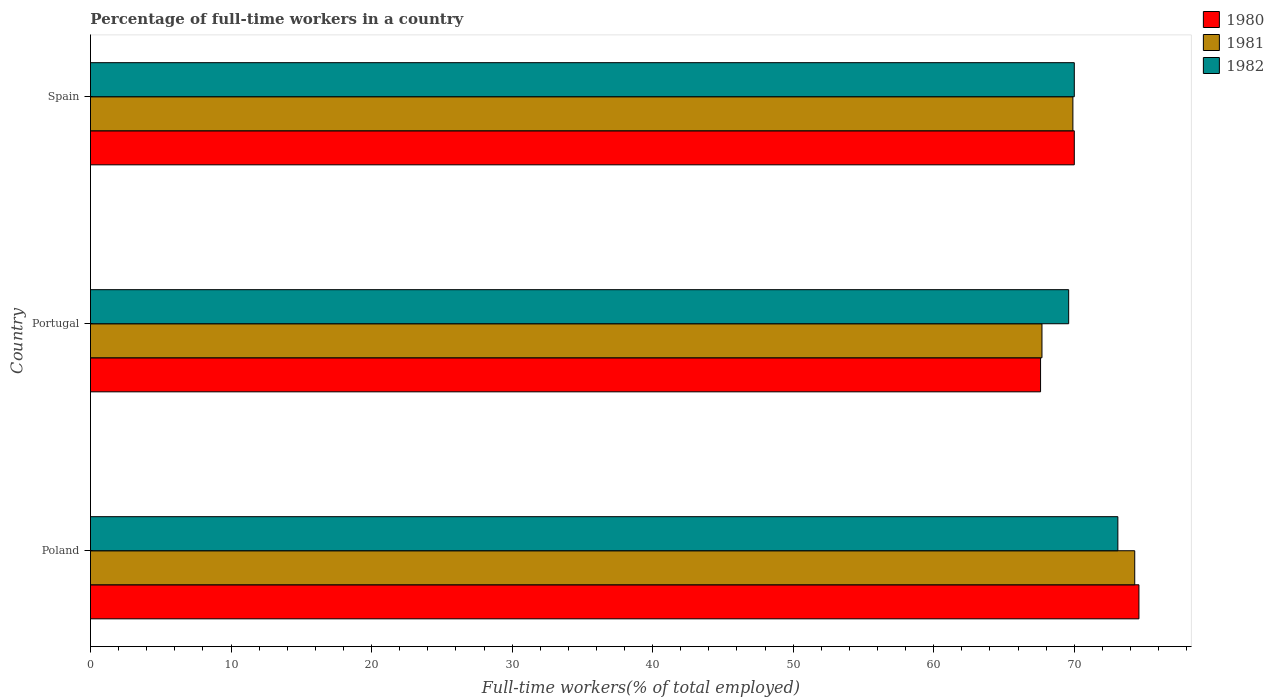How many different coloured bars are there?
Keep it short and to the point. 3. What is the label of the 1st group of bars from the top?
Provide a succinct answer. Spain. In how many cases, is the number of bars for a given country not equal to the number of legend labels?
Make the answer very short. 0. What is the percentage of full-time workers in 1981 in Portugal?
Ensure brevity in your answer.  67.7. Across all countries, what is the maximum percentage of full-time workers in 1982?
Keep it short and to the point. 73.1. Across all countries, what is the minimum percentage of full-time workers in 1981?
Your answer should be compact. 67.7. In which country was the percentage of full-time workers in 1981 maximum?
Your answer should be compact. Poland. What is the total percentage of full-time workers in 1980 in the graph?
Provide a short and direct response. 212.2. What is the difference between the percentage of full-time workers in 1981 in Poland and that in Portugal?
Your response must be concise. 6.6. What is the difference between the percentage of full-time workers in 1981 in Poland and the percentage of full-time workers in 1980 in Portugal?
Your answer should be very brief. 6.7. What is the average percentage of full-time workers in 1981 per country?
Provide a succinct answer. 70.63. What is the difference between the percentage of full-time workers in 1982 and percentage of full-time workers in 1980 in Poland?
Your response must be concise. -1.5. What is the ratio of the percentage of full-time workers in 1982 in Poland to that in Spain?
Ensure brevity in your answer.  1.04. What is the difference between the highest and the second highest percentage of full-time workers in 1981?
Your response must be concise. 4.4. What is the difference between the highest and the lowest percentage of full-time workers in 1981?
Provide a short and direct response. 6.6. In how many countries, is the percentage of full-time workers in 1981 greater than the average percentage of full-time workers in 1981 taken over all countries?
Ensure brevity in your answer.  1. Is the sum of the percentage of full-time workers in 1982 in Poland and Spain greater than the maximum percentage of full-time workers in 1981 across all countries?
Offer a very short reply. Yes. What does the 1st bar from the top in Portugal represents?
Keep it short and to the point. 1982. Does the graph contain any zero values?
Provide a short and direct response. No. How many legend labels are there?
Keep it short and to the point. 3. How are the legend labels stacked?
Provide a succinct answer. Vertical. What is the title of the graph?
Your answer should be very brief. Percentage of full-time workers in a country. What is the label or title of the X-axis?
Your response must be concise. Full-time workers(% of total employed). What is the label or title of the Y-axis?
Provide a short and direct response. Country. What is the Full-time workers(% of total employed) in 1980 in Poland?
Give a very brief answer. 74.6. What is the Full-time workers(% of total employed) in 1981 in Poland?
Offer a terse response. 74.3. What is the Full-time workers(% of total employed) in 1982 in Poland?
Give a very brief answer. 73.1. What is the Full-time workers(% of total employed) of 1980 in Portugal?
Give a very brief answer. 67.6. What is the Full-time workers(% of total employed) of 1981 in Portugal?
Keep it short and to the point. 67.7. What is the Full-time workers(% of total employed) of 1982 in Portugal?
Provide a succinct answer. 69.6. What is the Full-time workers(% of total employed) in 1981 in Spain?
Offer a very short reply. 69.9. What is the Full-time workers(% of total employed) in 1982 in Spain?
Offer a terse response. 70. Across all countries, what is the maximum Full-time workers(% of total employed) in 1980?
Give a very brief answer. 74.6. Across all countries, what is the maximum Full-time workers(% of total employed) of 1981?
Your answer should be very brief. 74.3. Across all countries, what is the maximum Full-time workers(% of total employed) of 1982?
Provide a short and direct response. 73.1. Across all countries, what is the minimum Full-time workers(% of total employed) of 1980?
Keep it short and to the point. 67.6. Across all countries, what is the minimum Full-time workers(% of total employed) of 1981?
Your response must be concise. 67.7. Across all countries, what is the minimum Full-time workers(% of total employed) of 1982?
Provide a succinct answer. 69.6. What is the total Full-time workers(% of total employed) of 1980 in the graph?
Your response must be concise. 212.2. What is the total Full-time workers(% of total employed) of 1981 in the graph?
Your answer should be very brief. 211.9. What is the total Full-time workers(% of total employed) in 1982 in the graph?
Provide a succinct answer. 212.7. What is the difference between the Full-time workers(% of total employed) of 1981 in Poland and that in Portugal?
Keep it short and to the point. 6.6. What is the difference between the Full-time workers(% of total employed) in 1982 in Poland and that in Portugal?
Your response must be concise. 3.5. What is the difference between the Full-time workers(% of total employed) of 1980 in Poland and that in Spain?
Provide a short and direct response. 4.6. What is the difference between the Full-time workers(% of total employed) in 1981 in Poland and that in Spain?
Offer a terse response. 4.4. What is the difference between the Full-time workers(% of total employed) of 1982 in Poland and that in Spain?
Your response must be concise. 3.1. What is the difference between the Full-time workers(% of total employed) of 1982 in Portugal and that in Spain?
Make the answer very short. -0.4. What is the difference between the Full-time workers(% of total employed) of 1980 in Poland and the Full-time workers(% of total employed) of 1982 in Portugal?
Offer a very short reply. 5. What is the difference between the Full-time workers(% of total employed) in 1981 in Poland and the Full-time workers(% of total employed) in 1982 in Spain?
Provide a succinct answer. 4.3. What is the difference between the Full-time workers(% of total employed) in 1980 in Portugal and the Full-time workers(% of total employed) in 1981 in Spain?
Keep it short and to the point. -2.3. What is the difference between the Full-time workers(% of total employed) of 1980 in Portugal and the Full-time workers(% of total employed) of 1982 in Spain?
Provide a succinct answer. -2.4. What is the difference between the Full-time workers(% of total employed) of 1981 in Portugal and the Full-time workers(% of total employed) of 1982 in Spain?
Make the answer very short. -2.3. What is the average Full-time workers(% of total employed) of 1980 per country?
Ensure brevity in your answer.  70.73. What is the average Full-time workers(% of total employed) of 1981 per country?
Offer a very short reply. 70.63. What is the average Full-time workers(% of total employed) in 1982 per country?
Keep it short and to the point. 70.9. What is the difference between the Full-time workers(% of total employed) in 1980 and Full-time workers(% of total employed) in 1981 in Poland?
Your response must be concise. 0.3. What is the difference between the Full-time workers(% of total employed) of 1980 and Full-time workers(% of total employed) of 1982 in Poland?
Offer a terse response. 1.5. What is the difference between the Full-time workers(% of total employed) in 1980 and Full-time workers(% of total employed) in 1981 in Portugal?
Offer a terse response. -0.1. What is the ratio of the Full-time workers(% of total employed) in 1980 in Poland to that in Portugal?
Provide a succinct answer. 1.1. What is the ratio of the Full-time workers(% of total employed) of 1981 in Poland to that in Portugal?
Give a very brief answer. 1.1. What is the ratio of the Full-time workers(% of total employed) in 1982 in Poland to that in Portugal?
Keep it short and to the point. 1.05. What is the ratio of the Full-time workers(% of total employed) of 1980 in Poland to that in Spain?
Provide a succinct answer. 1.07. What is the ratio of the Full-time workers(% of total employed) of 1981 in Poland to that in Spain?
Keep it short and to the point. 1.06. What is the ratio of the Full-time workers(% of total employed) of 1982 in Poland to that in Spain?
Make the answer very short. 1.04. What is the ratio of the Full-time workers(% of total employed) of 1980 in Portugal to that in Spain?
Your answer should be very brief. 0.97. What is the ratio of the Full-time workers(% of total employed) of 1981 in Portugal to that in Spain?
Your answer should be very brief. 0.97. What is the ratio of the Full-time workers(% of total employed) of 1982 in Portugal to that in Spain?
Provide a succinct answer. 0.99. What is the difference between the highest and the second highest Full-time workers(% of total employed) of 1980?
Offer a very short reply. 4.6. What is the difference between the highest and the second highest Full-time workers(% of total employed) in 1981?
Give a very brief answer. 4.4. What is the difference between the highest and the second highest Full-time workers(% of total employed) in 1982?
Your answer should be very brief. 3.1. What is the difference between the highest and the lowest Full-time workers(% of total employed) in 1982?
Give a very brief answer. 3.5. 